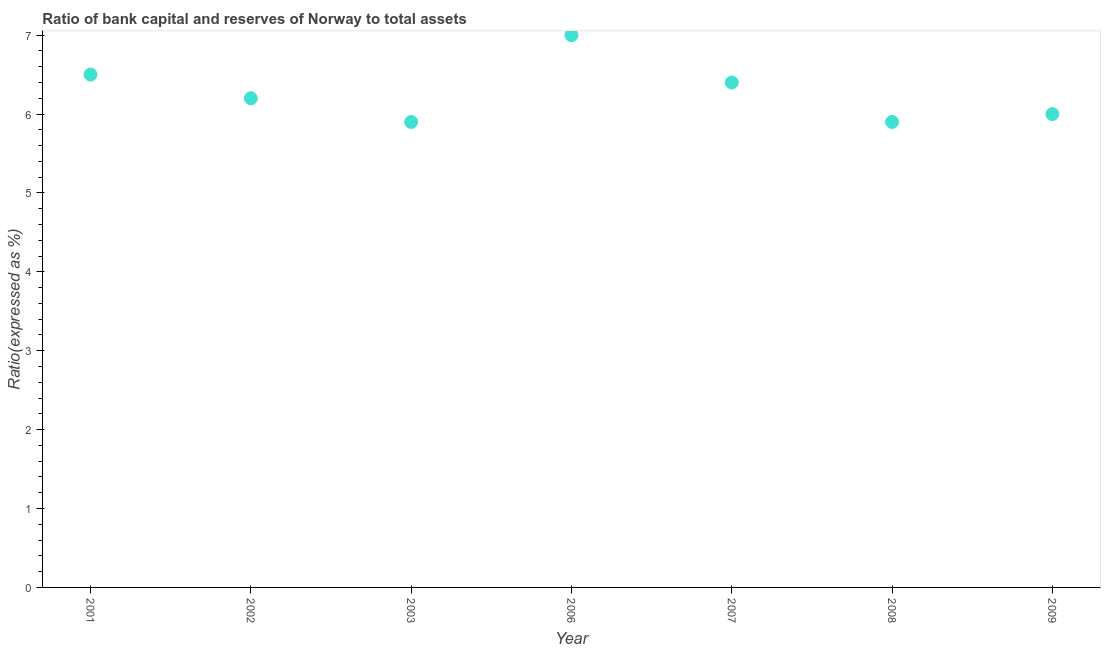What is the bank capital to assets ratio in 2001?
Provide a short and direct response. 6.5. Across all years, what is the minimum bank capital to assets ratio?
Your answer should be compact. 5.9. In which year was the bank capital to assets ratio maximum?
Offer a very short reply. 2006. What is the sum of the bank capital to assets ratio?
Provide a short and direct response. 43.9. What is the difference between the bank capital to assets ratio in 2002 and 2007?
Give a very brief answer. -0.2. What is the average bank capital to assets ratio per year?
Make the answer very short. 6.27. What is the median bank capital to assets ratio?
Provide a short and direct response. 6.2. In how many years, is the bank capital to assets ratio greater than 5.4 %?
Ensure brevity in your answer.  7. Do a majority of the years between 2009 and 2003 (inclusive) have bank capital to assets ratio greater than 2 %?
Offer a very short reply. Yes. What is the ratio of the bank capital to assets ratio in 2006 to that in 2008?
Ensure brevity in your answer.  1.19. Is the bank capital to assets ratio in 2003 less than that in 2009?
Your answer should be very brief. Yes. Is the difference between the bank capital to assets ratio in 2007 and 2009 greater than the difference between any two years?
Make the answer very short. No. What is the difference between the highest and the lowest bank capital to assets ratio?
Provide a short and direct response. 1.1. In how many years, is the bank capital to assets ratio greater than the average bank capital to assets ratio taken over all years?
Offer a very short reply. 3. What is the title of the graph?
Provide a short and direct response. Ratio of bank capital and reserves of Norway to total assets. What is the label or title of the X-axis?
Provide a succinct answer. Year. What is the label or title of the Y-axis?
Provide a succinct answer. Ratio(expressed as %). What is the Ratio(expressed as %) in 2001?
Keep it short and to the point. 6.5. What is the Ratio(expressed as %) in 2003?
Your response must be concise. 5.9. What is the Ratio(expressed as %) in 2006?
Provide a succinct answer. 7. What is the Ratio(expressed as %) in 2008?
Offer a terse response. 5.9. What is the Ratio(expressed as %) in 2009?
Provide a short and direct response. 6. What is the difference between the Ratio(expressed as %) in 2001 and 2002?
Your response must be concise. 0.3. What is the difference between the Ratio(expressed as %) in 2001 and 2003?
Give a very brief answer. 0.6. What is the difference between the Ratio(expressed as %) in 2001 and 2006?
Keep it short and to the point. -0.5. What is the difference between the Ratio(expressed as %) in 2001 and 2007?
Offer a terse response. 0.1. What is the difference between the Ratio(expressed as %) in 2001 and 2008?
Your answer should be very brief. 0.6. What is the difference between the Ratio(expressed as %) in 2001 and 2009?
Offer a terse response. 0.5. What is the difference between the Ratio(expressed as %) in 2002 and 2003?
Provide a succinct answer. 0.3. What is the difference between the Ratio(expressed as %) in 2002 and 2007?
Give a very brief answer. -0.2. What is the difference between the Ratio(expressed as %) in 2002 and 2008?
Ensure brevity in your answer.  0.3. What is the difference between the Ratio(expressed as %) in 2002 and 2009?
Offer a very short reply. 0.2. What is the difference between the Ratio(expressed as %) in 2003 and 2006?
Offer a terse response. -1.1. What is the difference between the Ratio(expressed as %) in 2003 and 2007?
Give a very brief answer. -0.5. What is the difference between the Ratio(expressed as %) in 2003 and 2008?
Ensure brevity in your answer.  0. What is the difference between the Ratio(expressed as %) in 2003 and 2009?
Make the answer very short. -0.1. What is the difference between the Ratio(expressed as %) in 2006 and 2009?
Give a very brief answer. 1. What is the ratio of the Ratio(expressed as %) in 2001 to that in 2002?
Give a very brief answer. 1.05. What is the ratio of the Ratio(expressed as %) in 2001 to that in 2003?
Provide a short and direct response. 1.1. What is the ratio of the Ratio(expressed as %) in 2001 to that in 2006?
Offer a very short reply. 0.93. What is the ratio of the Ratio(expressed as %) in 2001 to that in 2007?
Your answer should be compact. 1.02. What is the ratio of the Ratio(expressed as %) in 2001 to that in 2008?
Your response must be concise. 1.1. What is the ratio of the Ratio(expressed as %) in 2001 to that in 2009?
Your response must be concise. 1.08. What is the ratio of the Ratio(expressed as %) in 2002 to that in 2003?
Keep it short and to the point. 1.05. What is the ratio of the Ratio(expressed as %) in 2002 to that in 2006?
Your answer should be very brief. 0.89. What is the ratio of the Ratio(expressed as %) in 2002 to that in 2008?
Offer a terse response. 1.05. What is the ratio of the Ratio(expressed as %) in 2002 to that in 2009?
Give a very brief answer. 1.03. What is the ratio of the Ratio(expressed as %) in 2003 to that in 2006?
Provide a short and direct response. 0.84. What is the ratio of the Ratio(expressed as %) in 2003 to that in 2007?
Make the answer very short. 0.92. What is the ratio of the Ratio(expressed as %) in 2003 to that in 2008?
Keep it short and to the point. 1. What is the ratio of the Ratio(expressed as %) in 2006 to that in 2007?
Offer a terse response. 1.09. What is the ratio of the Ratio(expressed as %) in 2006 to that in 2008?
Your answer should be very brief. 1.19. What is the ratio of the Ratio(expressed as %) in 2006 to that in 2009?
Your answer should be very brief. 1.17. What is the ratio of the Ratio(expressed as %) in 2007 to that in 2008?
Make the answer very short. 1.08. What is the ratio of the Ratio(expressed as %) in 2007 to that in 2009?
Make the answer very short. 1.07. 